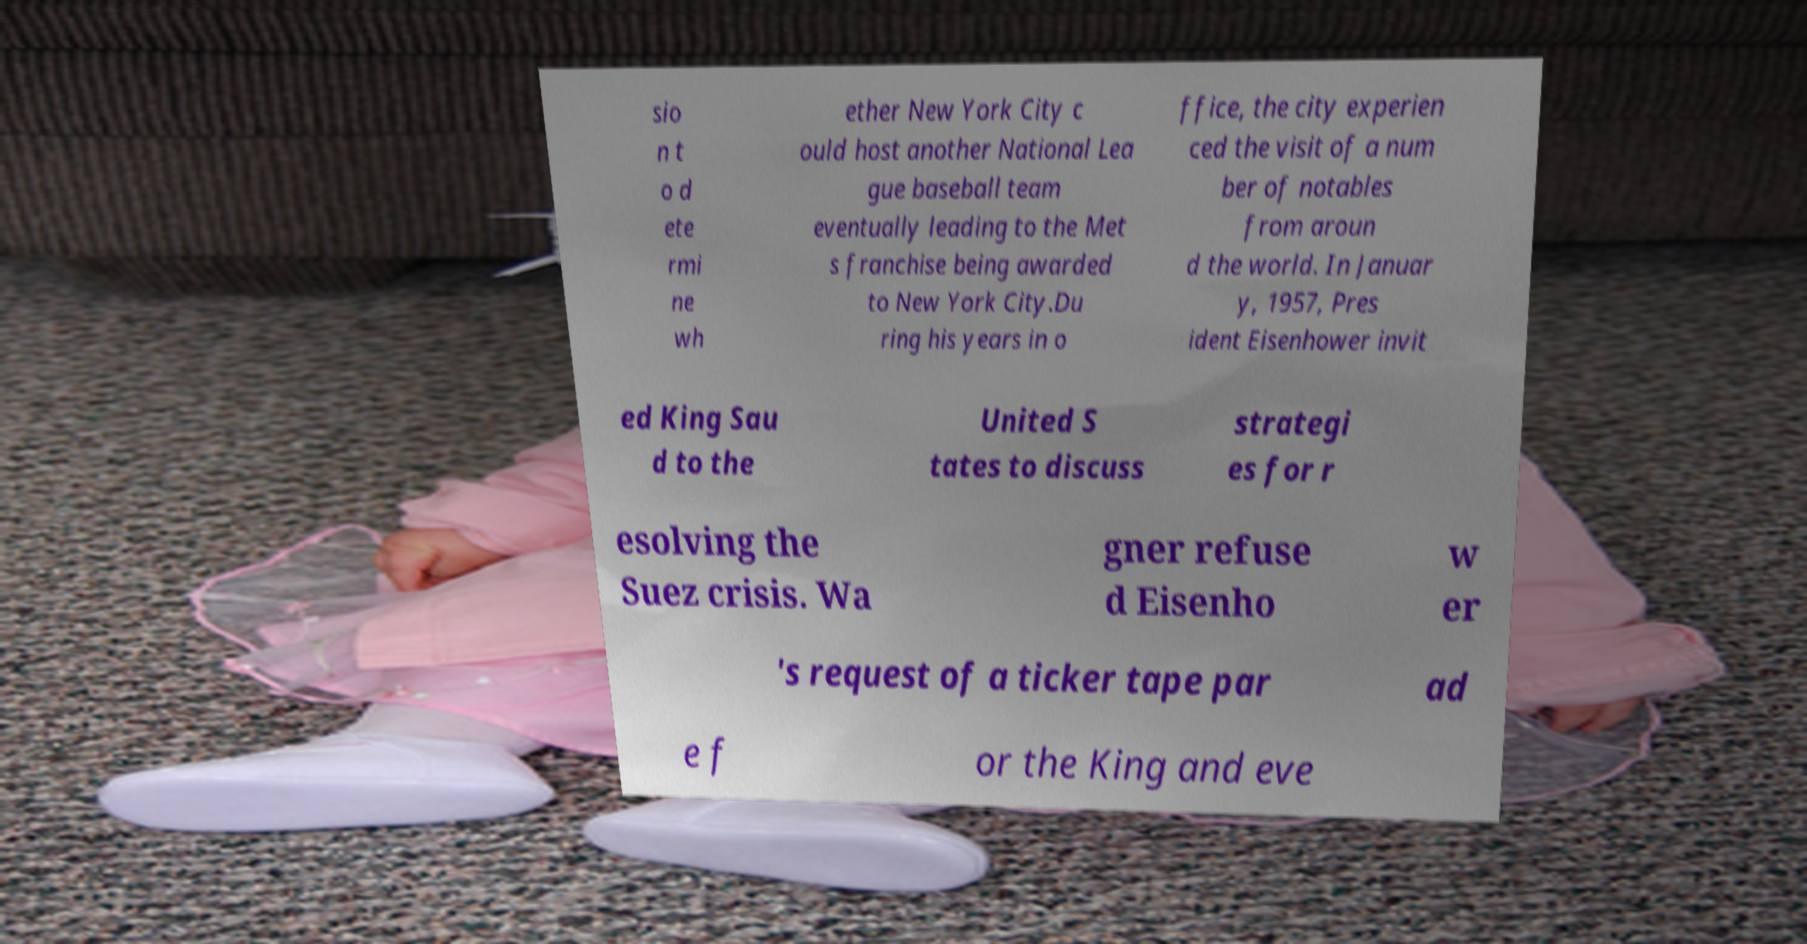Please read and relay the text visible in this image. What does it say? sio n t o d ete rmi ne wh ether New York City c ould host another National Lea gue baseball team eventually leading to the Met s franchise being awarded to New York City.Du ring his years in o ffice, the city experien ced the visit of a num ber of notables from aroun d the world. In Januar y, 1957, Pres ident Eisenhower invit ed King Sau d to the United S tates to discuss strategi es for r esolving the Suez crisis. Wa gner refuse d Eisenho w er 's request of a ticker tape par ad e f or the King and eve 